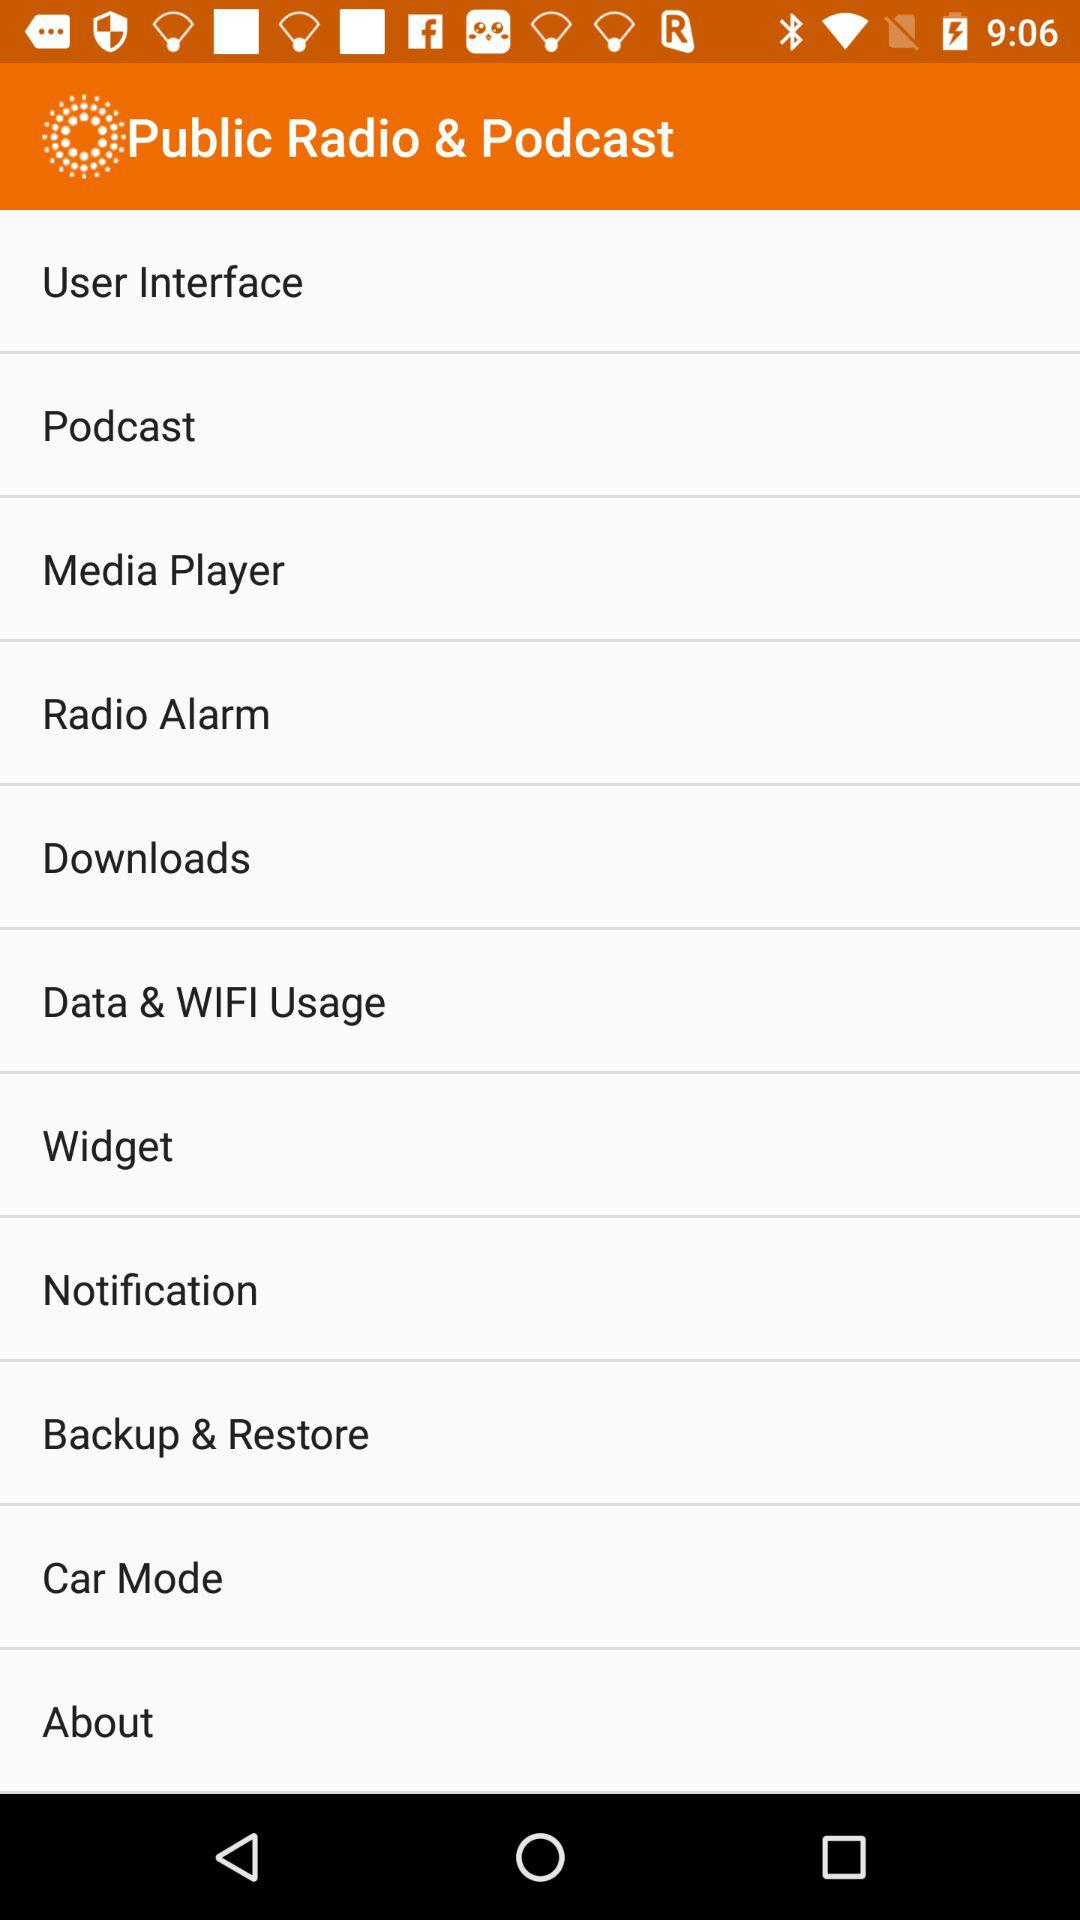What is the application name? The application name is "Public Radio & Podcast". 